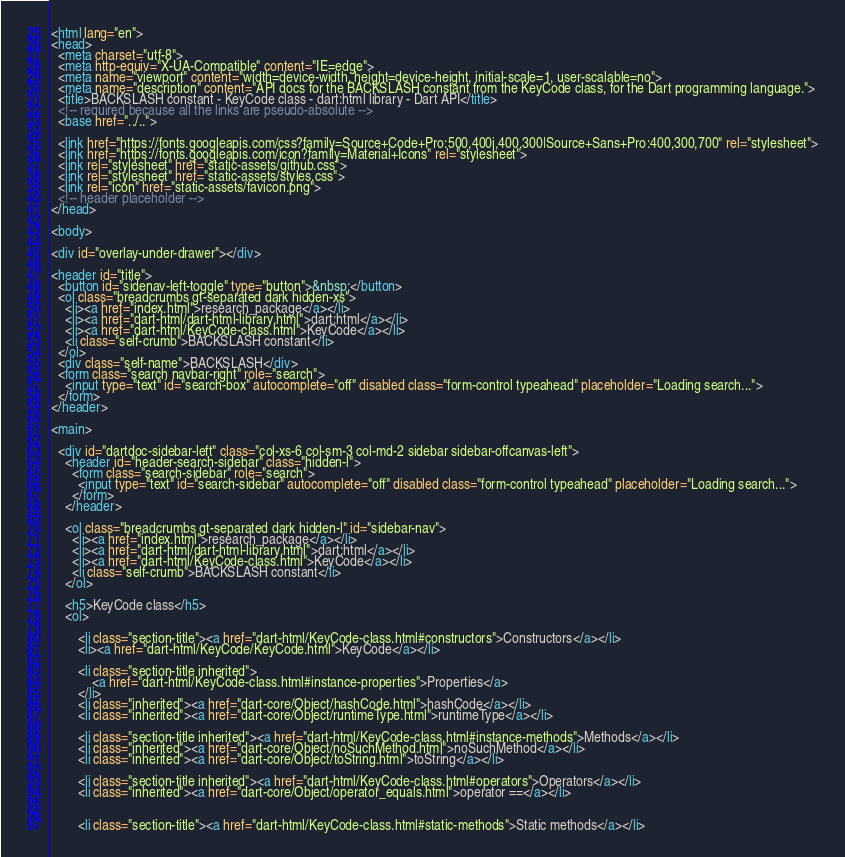Convert code to text. <code><loc_0><loc_0><loc_500><loc_500><_HTML_><html lang="en">
<head>
  <meta charset="utf-8">
  <meta http-equiv="X-UA-Compatible" content="IE=edge">
  <meta name="viewport" content="width=device-width, height=device-height, initial-scale=1, user-scalable=no">
  <meta name="description" content="API docs for the BACKSLASH constant from the KeyCode class, for the Dart programming language.">
  <title>BACKSLASH constant - KeyCode class - dart:html library - Dart API</title>
  <!-- required because all the links are pseudo-absolute -->
  <base href="../..">

  <link href="https://fonts.googleapis.com/css?family=Source+Code+Pro:500,400i,400,300|Source+Sans+Pro:400,300,700" rel="stylesheet">
  <link href="https://fonts.googleapis.com/icon?family=Material+Icons" rel="stylesheet">
  <link rel="stylesheet" href="static-assets/github.css">
  <link rel="stylesheet" href="static-assets/styles.css">
  <link rel="icon" href="static-assets/favicon.png">
  <!-- header placeholder -->
</head>

<body>

<div id="overlay-under-drawer"></div>

<header id="title">
  <button id="sidenav-left-toggle" type="button">&nbsp;</button>
  <ol class="breadcrumbs gt-separated dark hidden-xs">
    <li><a href="index.html">research_package</a></li>
    <li><a href="dart-html/dart-html-library.html">dart:html</a></li>
    <li><a href="dart-html/KeyCode-class.html">KeyCode</a></li>
    <li class="self-crumb">BACKSLASH constant</li>
  </ol>
  <div class="self-name">BACKSLASH</div>
  <form class="search navbar-right" role="search">
    <input type="text" id="search-box" autocomplete="off" disabled class="form-control typeahead" placeholder="Loading search...">
  </form>
</header>

<main>

  <div id="dartdoc-sidebar-left" class="col-xs-6 col-sm-3 col-md-2 sidebar sidebar-offcanvas-left">
    <header id="header-search-sidebar" class="hidden-l">
      <form class="search-sidebar" role="search">
        <input type="text" id="search-sidebar" autocomplete="off" disabled class="form-control typeahead" placeholder="Loading search...">
      </form>
    </header>
    
    <ol class="breadcrumbs gt-separated dark hidden-l" id="sidebar-nav">
      <li><a href="index.html">research_package</a></li>
      <li><a href="dart-html/dart-html-library.html">dart:html</a></li>
      <li><a href="dart-html/KeyCode-class.html">KeyCode</a></li>
      <li class="self-crumb">BACKSLASH constant</li>
    </ol>
    
    <h5>KeyCode class</h5>
    <ol>
    
        <li class="section-title"><a href="dart-html/KeyCode-class.html#constructors">Constructors</a></li>
        <li><a href="dart-html/KeyCode/KeyCode.html">KeyCode</a></li>
    
        <li class="section-title inherited">
            <a href="dart-html/KeyCode-class.html#instance-properties">Properties</a>
        </li>
        <li class="inherited"><a href="dart-core/Object/hashCode.html">hashCode</a></li>
        <li class="inherited"><a href="dart-core/Object/runtimeType.html">runtimeType</a></li>
    
        <li class="section-title inherited"><a href="dart-html/KeyCode-class.html#instance-methods">Methods</a></li>
        <li class="inherited"><a href="dart-core/Object/noSuchMethod.html">noSuchMethod</a></li>
        <li class="inherited"><a href="dart-core/Object/toString.html">toString</a></li>
    
        <li class="section-title inherited"><a href="dart-html/KeyCode-class.html#operators">Operators</a></li>
        <li class="inherited"><a href="dart-core/Object/operator_equals.html">operator ==</a></li>
    
    
        <li class="section-title"><a href="dart-html/KeyCode-class.html#static-methods">Static methods</a></li></code> 